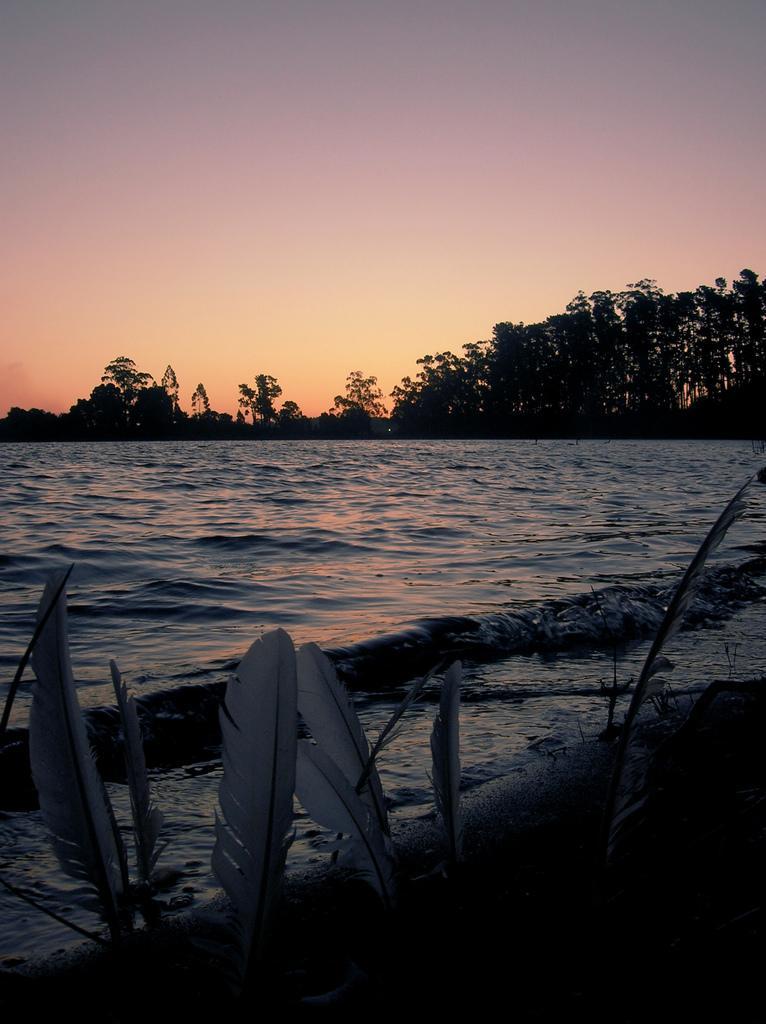In one or two sentences, can you explain what this image depicts? In this image in the center there is a river and in the foreground there are some plants, in the background there are some trees and at the top of the image there is sky. 